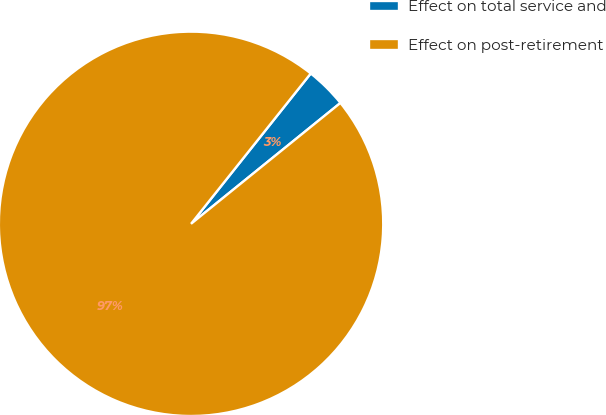Convert chart. <chart><loc_0><loc_0><loc_500><loc_500><pie_chart><fcel>Effect on total service and<fcel>Effect on post-retirement<nl><fcel>3.47%<fcel>96.53%<nl></chart> 